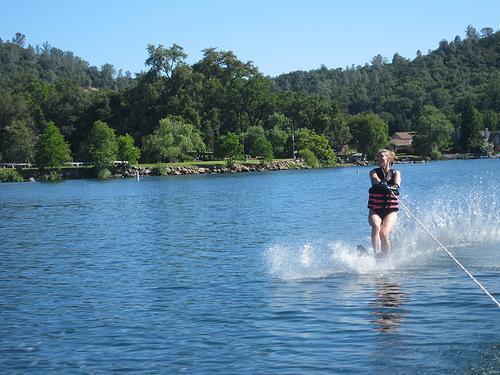How many people are there?
Give a very brief answer. 1. 